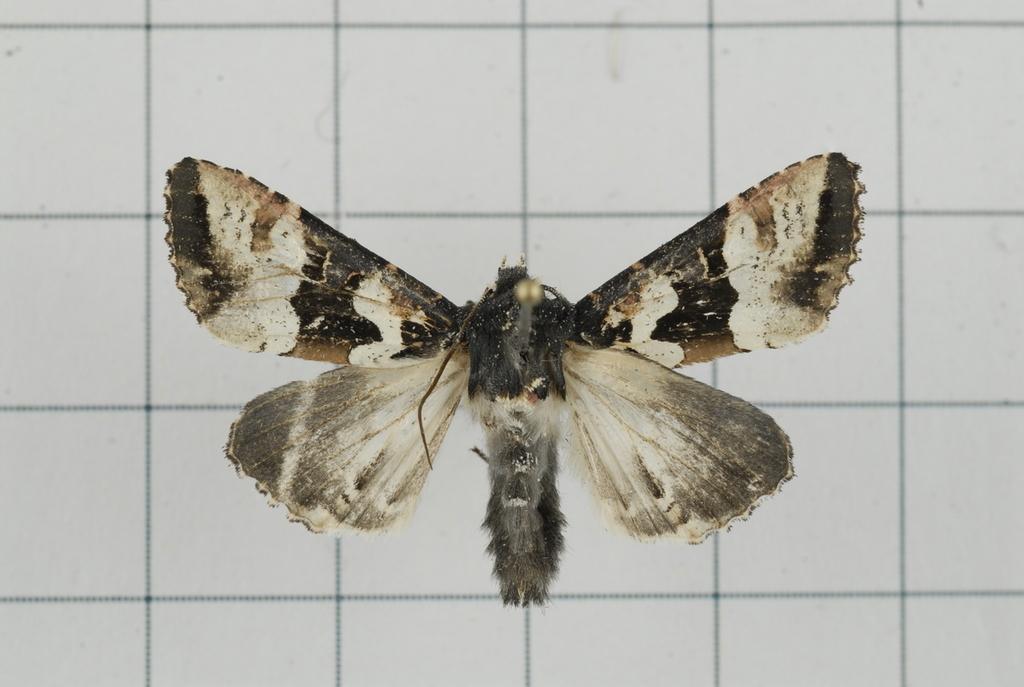Describe this image in one or two sentences. In this image there is an insect in the front. In the background there is a wall. 